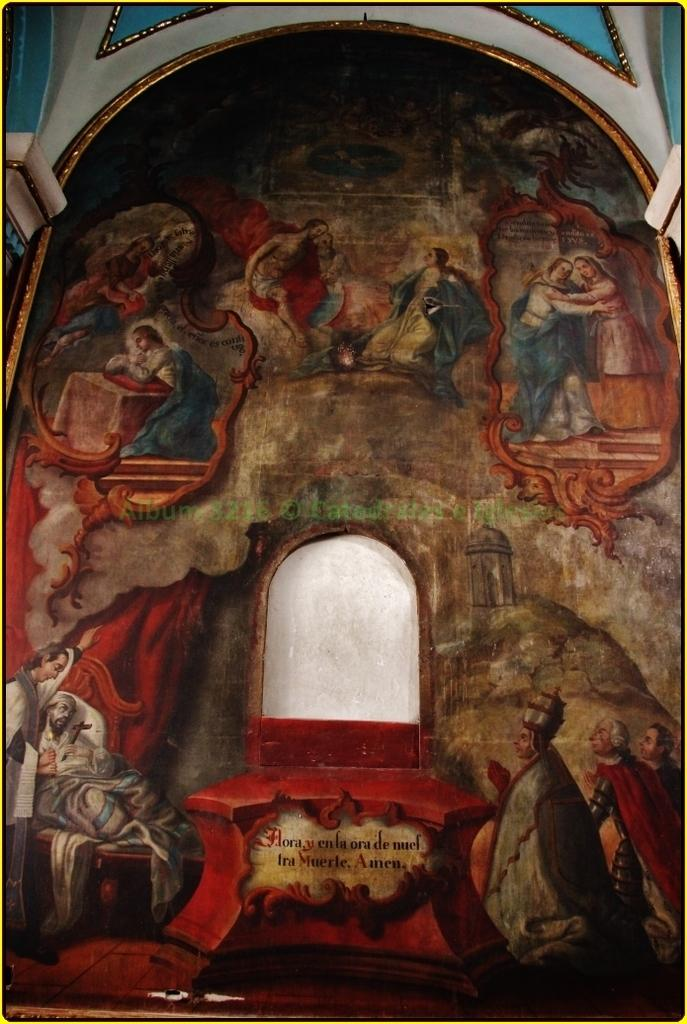What is on the wall in the image? There is a frame on the wall in the image. What can be seen inside the frame? There are people inside the frame. How many pigs are visible inside the frame? There are no pigs visible inside the frame; it contains people. What type of ant can be seen crawling on the frame? There is no ant present on the frame or in the image. 